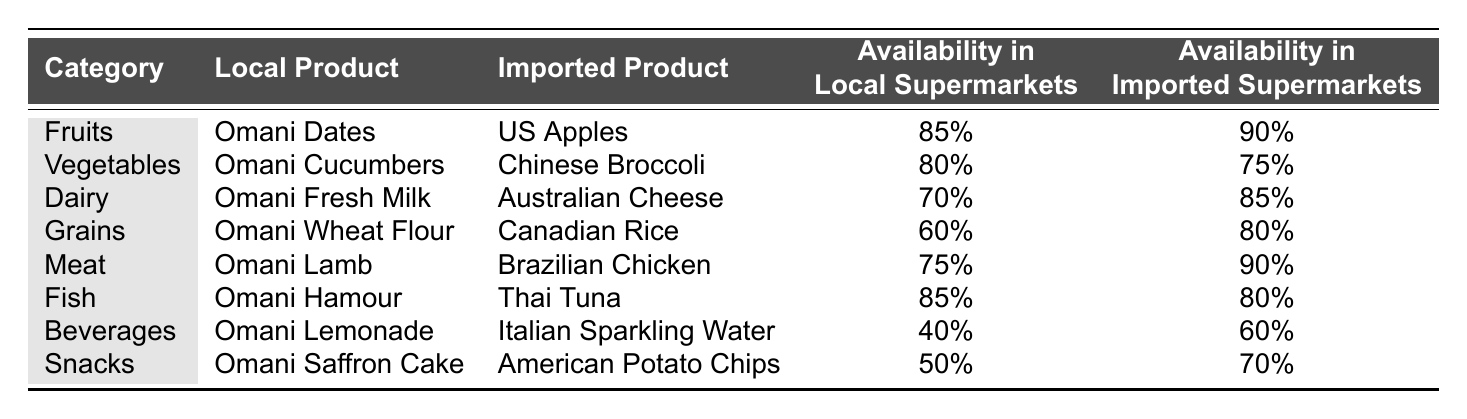What is the availability percentage of Omani Dates in local supermarkets? The table indicates that the availability of Omani Dates in local supermarkets is listed as 85%.
Answer: 85% Which local product has the highest availability in local supermarkets? By comparing the availability percentages for all local products, Omani Dates and Omani Hamour both have the highest availability at 85%.
Answer: Omani Dates and Omani Hamour Is the availability of Omani Lemonade in local supermarkets greater than 50%? The table shows the availability of Omani Lemonade in local supermarkets is 40%, which is less than 50%.
Answer: No How does the availability of Omani Fresh Milk compare to that of Australian Cheese in local supermarkets? The availability of Omani Fresh Milk is 70% in local supermarkets, whereas Australian Cheese is not available in local supermarkets (with the table indicating 70% for local products). Thus, Omani Fresh Milk has a presence, unlike Australian Cheese in local supermarkets.
Answer: Omani Fresh Milk is available, Australian Cheese is not What is the difference in availability percentages between Omani Lamb and Brazilian Chicken in imported supermarkets? The table provides the availability of Omani Lamb in imported supermarkets as 75% and Brazilian Chicken as 90%. The difference is calculated as 90% - 75% = 15%.
Answer: 15% What is the average availability percentage of local products across all categories? To find the average, add the availability percentages of local products: 85% (Dates) + 80% (Cucumbers) + 70% (Fresh Milk) + 60% (Wheat Flour) + 75% (Lamb) + 85% (Hamour) + 40% (Lemonade) + 50% (Saffron Cake) = 595%. There are 8 categories, so the average is 595% / 8 = 74.375%.
Answer: 74.375% Which category has a higher availability for local products compared to imported products? By analyzing the table, Omani Cucumbers, Omani Hamour, and Omani Dates show higher availability percentages in local supermarkets compared to their imported counterparts (80% vs 75% for Cucumbers, 85% vs 80% for Hamour, and 85% vs 90% for Dates).
Answer: Fruits and Vegetables Is the availability of imported products generally higher than that of local products in all categories? The comparison reveals that in some categories, such as Dairy and Grains, imported products have higher availability percentages, while local products like Omani Dates, Cucumbers, and Hamour have higher availability, indicating that it's not true for all categories.
Answer: No 